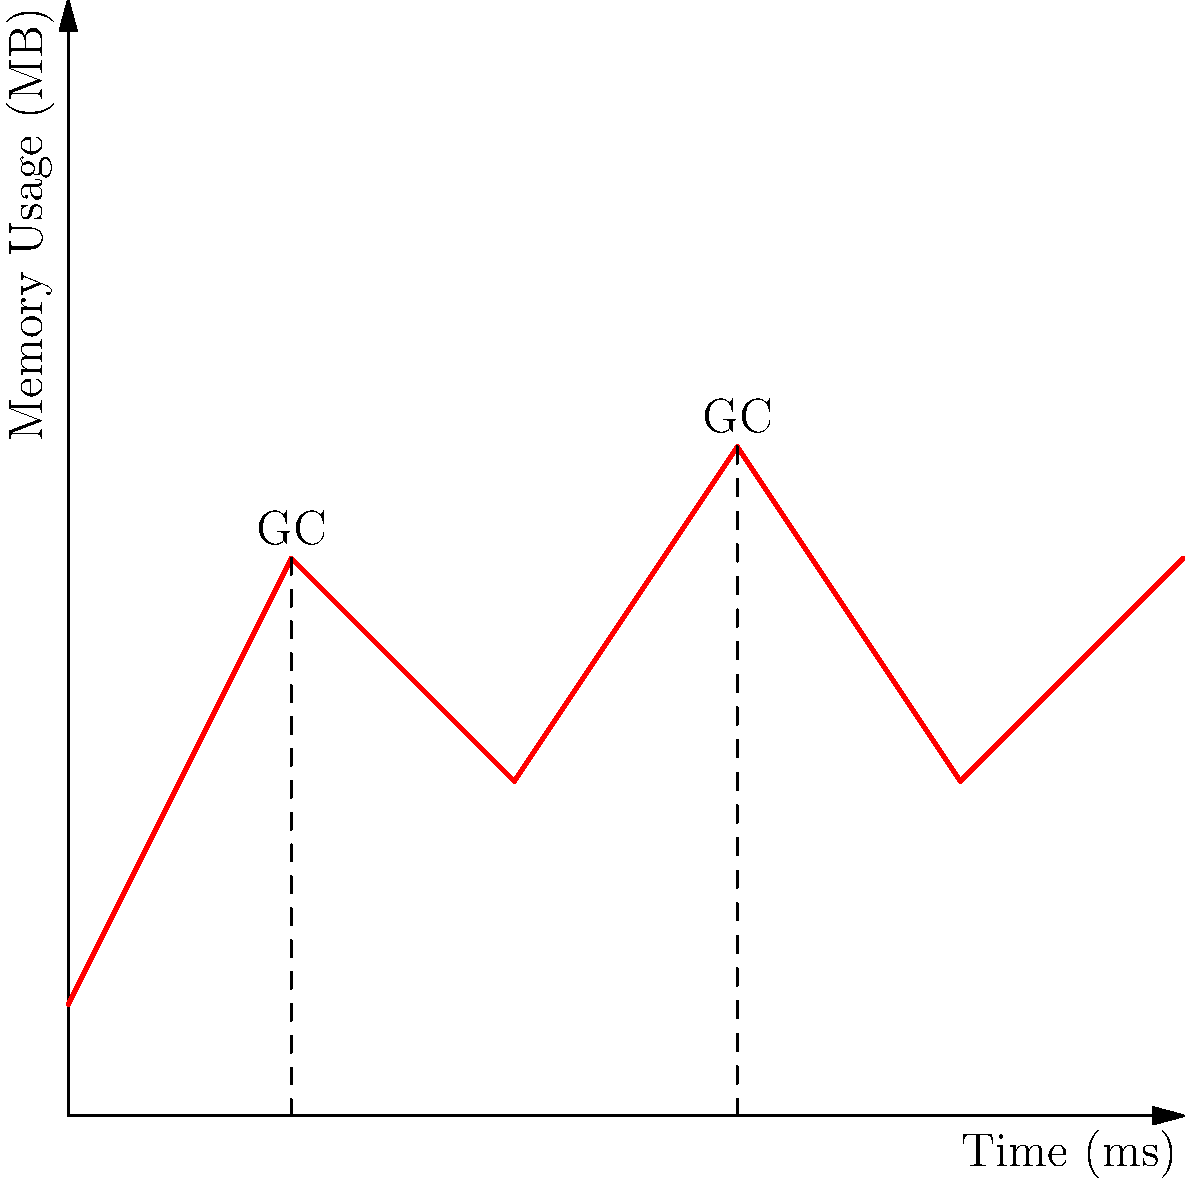The graph above illustrates the memory usage pattern of a Go program over time. Based on the syntax and semantics of Go's memory management, explain the observed pattern and identify the points where garbage collection likely occurs. How does this process contribute to Go's efficient memory management, and what implications does it have for writing performant Go code? 1. Initial allocation: The graph shows an initial linear increase in memory usage from 0 to 20ms, representing the allocation of objects during program execution.

2. First garbage collection (GC) at 20ms:
   - The sharp decrease in memory usage indicates a garbage collection event.
   - Go's garbage collector identifies and frees memory that is no longer in use.

3. Memory usage pattern between 20ms and 60ms:
   - After the first GC, memory usage increases again, but at a slower rate.
   - This suggests that some objects from the initial allocation were long-lived and survived the GC.

4. Second garbage collection at 60ms:
   - Another sharp decrease in memory usage, indicating another GC event.
   - The peak before this GC is higher than the first, suggesting more accumulated objects.

5. Final segment (60ms to 100ms):
   - Memory usage increases again, but at a different rate than before.

Key points about Go's memory management:

a) Concurrent garbage collection: Go's GC runs concurrently with the program, minimizing pause times.

b) Mark-and-sweep algorithm: Go uses a non-generational, non-compacting collector that marks live objects and sweeps unmarked ones.

c) Trigger heuristics: GC is triggered based on heap size growth and allocation rate, not fixed time intervals.

d) Escape analysis: Go's compiler performs escape analysis to determine which objects can be allocated on the stack instead of the heap, reducing GC pressure.

Implications for writing performant Go code:

1. Minimize allocations: Reduce the number of heap allocations to lower GC overhead.
2. Object reuse: Use object pools for frequently created and discarded objects.
3. Avoid unnecessary pointers: Use value types where possible to reduce GC scan times.
4. Optimize for locality: Group related data to improve cache efficiency and reduce GC work.
5. Be aware of GC triggers: Large heap sizes or high allocation rates can lead to more frequent GC cycles.
Answer: Concurrent mark-and-sweep GC at 20ms and 60ms; efficient memory management through escape analysis, object reuse, and minimizing allocations. 